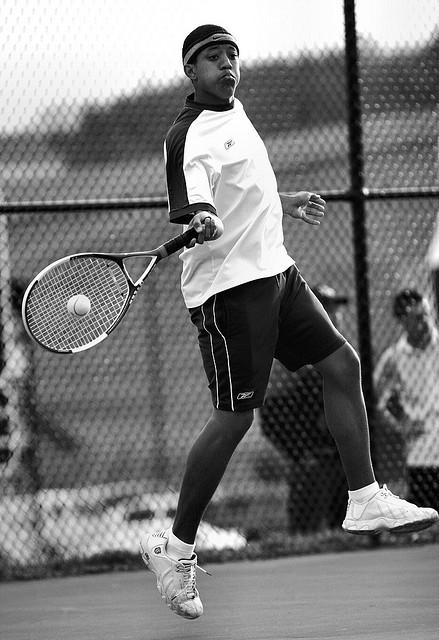Is the boy wearing a belt?
Concise answer only. No. Is the player jumping?
Give a very brief answer. Yes. What is the player holding in his arms?
Short answer required. Tennis racket. What is the color of the ball?
Answer briefly. White. What color is the tennis ball?
Concise answer only. White. What is this sport?
Concise answer only. Tennis. What sport is depicted?
Be succinct. Tennis. Did he just do the jazz hand while hitting the ball?
Answer briefly. No. How many tennis balls are in this photo?
Keep it brief. 1. What color are his shorts?
Give a very brief answer. Black. 